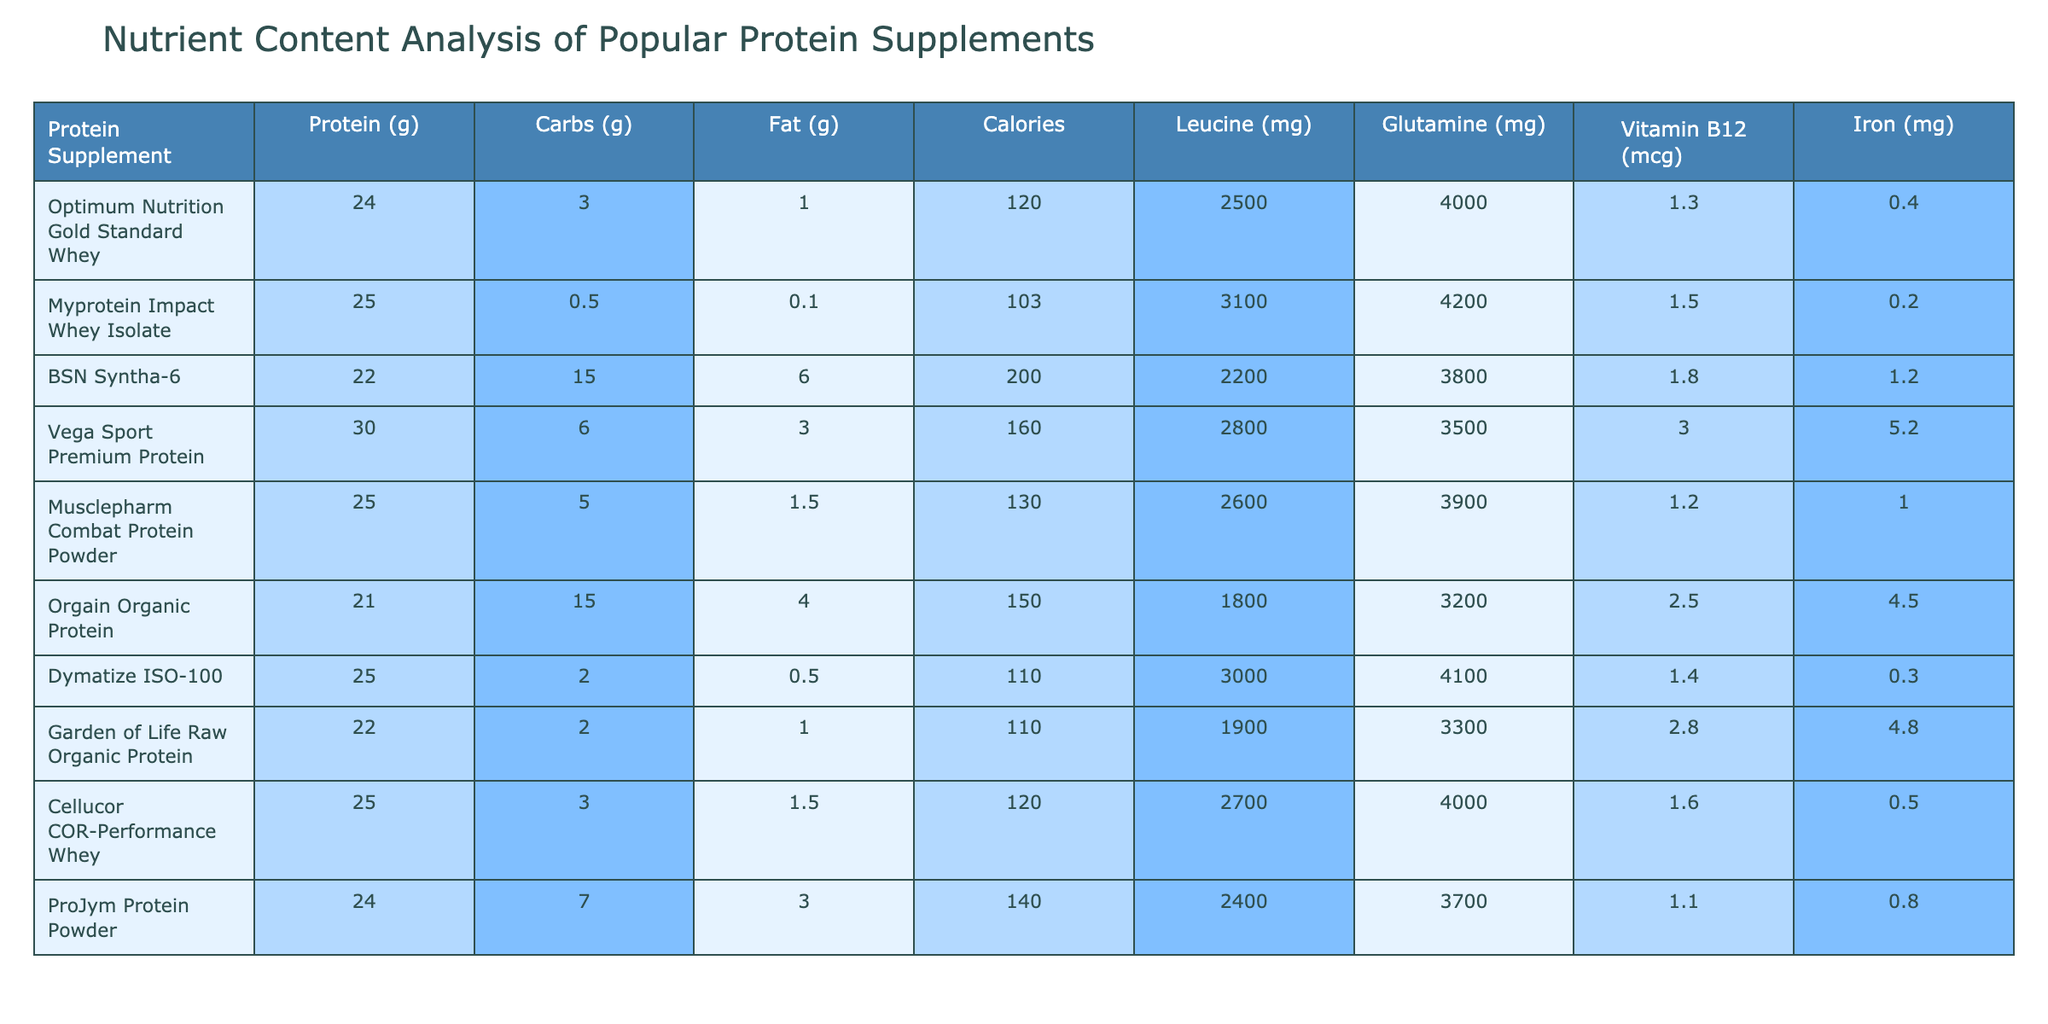What is the protein content of Myprotein Impact Whey Isolate? The table shows that Myprotein Impact Whey Isolate has a protein content of 25 grams.
Answer: 25 grams Which protein supplement contains the highest amount of fat? By comparing the fat content in the table, BSN Syntha-6 has 6 grams of fat, which is the highest among all listed supplements.
Answer: BSN Syntha-6 What is the total carbohydrate content of Orgain Organic Protein and Vega Sport Premium Protein combined? Orgain Organic Protein has 15 grams of carbs and Vega Sport Premium Protein has 6 grams. The total is 15 + 6 = 21 grams.
Answer: 21 grams Does Dymatize ISO-100 contain more leucine than ProJym Protein Powder? Dymatize ISO-100 has 3000 mg of leucine, while ProJym Protein Powder has 2400 mg. Thus, Dymatize ISO-100 contains more leucine.
Answer: Yes What is the average calorie content of the protein supplements listed in the table? The calorie values are: 120, 103, 200, 160, 130, 150, 110, 110, 120, and 140. The sum is 1,440 calories, and dividing by 10 gives an average of 144 calories.
Answer: 144 calories Which protein supplement has the lowest iron content? By examining the iron content, Myprotein Impact Whey Isolate has the lowest at 0.2 mg, compared to the others that have higher values.
Answer: Myprotein Impact Whey Isolate What is the difference in protein content between Optimum Nutrition Gold Standard Whey and Musclepharm Combat Protein Powder? Optimum Nutrition Gold Standard Whey has 24 grams of protein, while Musclepharm Combat Protein Powder has 25 grams. The difference is 25 - 24 = 1 gram.
Answer: 1 gram Which protein supplement is likely best for someone needing more Vitamin B12? Vega Sport Premium Protein has the highest Vitamin B12 content at 3.0 mcg compared to others in the table.
Answer: Vega Sport Premium Protein What supplement provides the most glutamine per serving? By checking the glutamine content, Myprotein Impact Whey Isolate has the highest at 4200 mg compared to others, therefore it provides the most glutamine.
Answer: Myprotein Impact Whey Isolate If a fitness enthusiast is looking for a supplement with at least 20 grams of protein and less than 5 grams of fat, which options do they have? The options that meet these criteria are Myprotein Impact Whey Isolate (25g protein, 0.1g fat), Dymatize ISO-100 (25g protein, 0.5g fat), and Musclepharm Combat Protein Powder (25g protein, 1.5g fat).
Answer: Myprotein Impact Whey Isolate, Dymatize ISO-100, Musclepharm Combat Protein Powder 